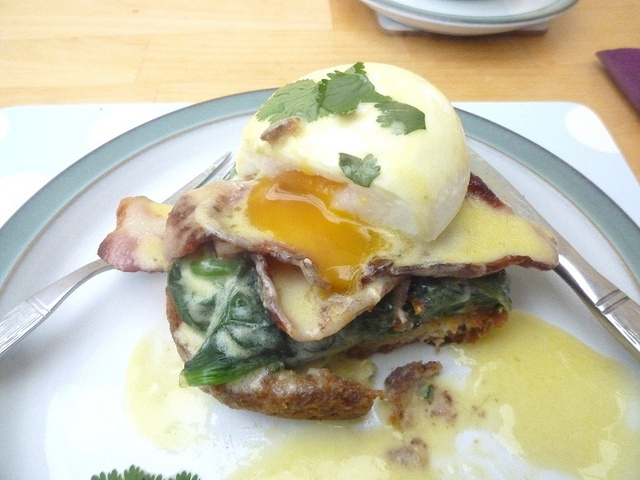Describe the objects in this image and their specific colors. I can see sandwich in beige, khaki, tan, and darkgray tones, dining table in tan, ivory, and khaki tones, knife in beige, darkgray, white, gray, and tan tones, and fork in beige, lightgray, and darkgray tones in this image. 